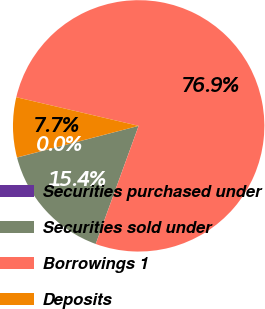Convert chart. <chart><loc_0><loc_0><loc_500><loc_500><pie_chart><fcel>Securities purchased under<fcel>Securities sold under<fcel>Borrowings 1<fcel>Deposits<nl><fcel>0.02%<fcel>15.39%<fcel>76.89%<fcel>7.7%<nl></chart> 